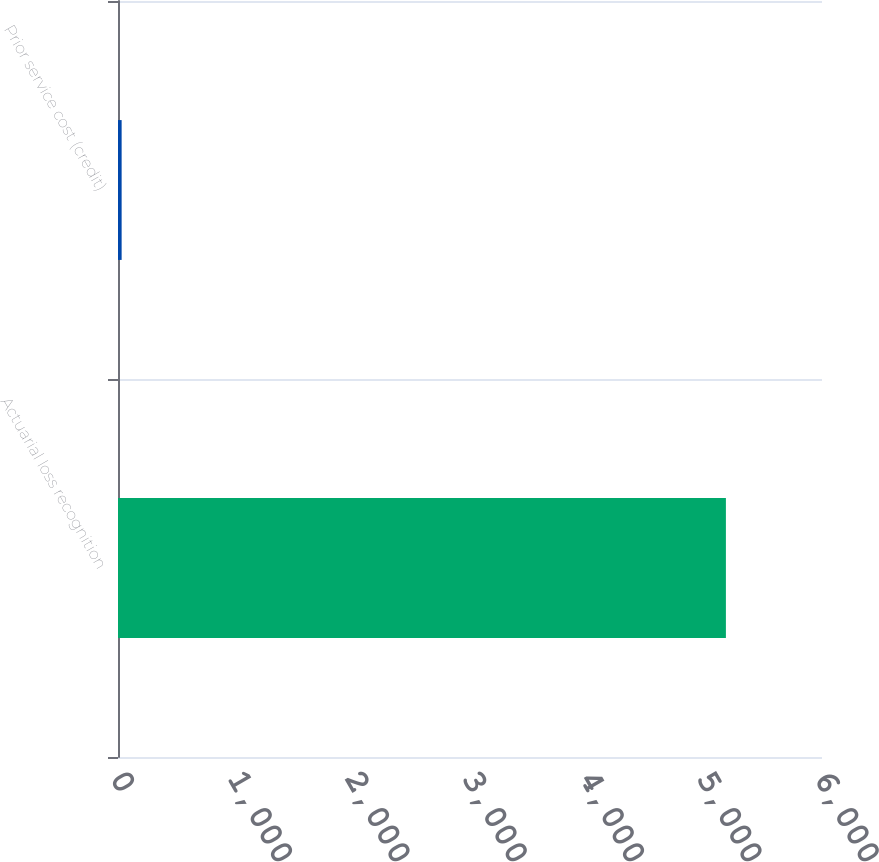Convert chart. <chart><loc_0><loc_0><loc_500><loc_500><bar_chart><fcel>Actuarial loss recognition<fcel>Prior service cost (credit)<nl><fcel>5181<fcel>31<nl></chart> 